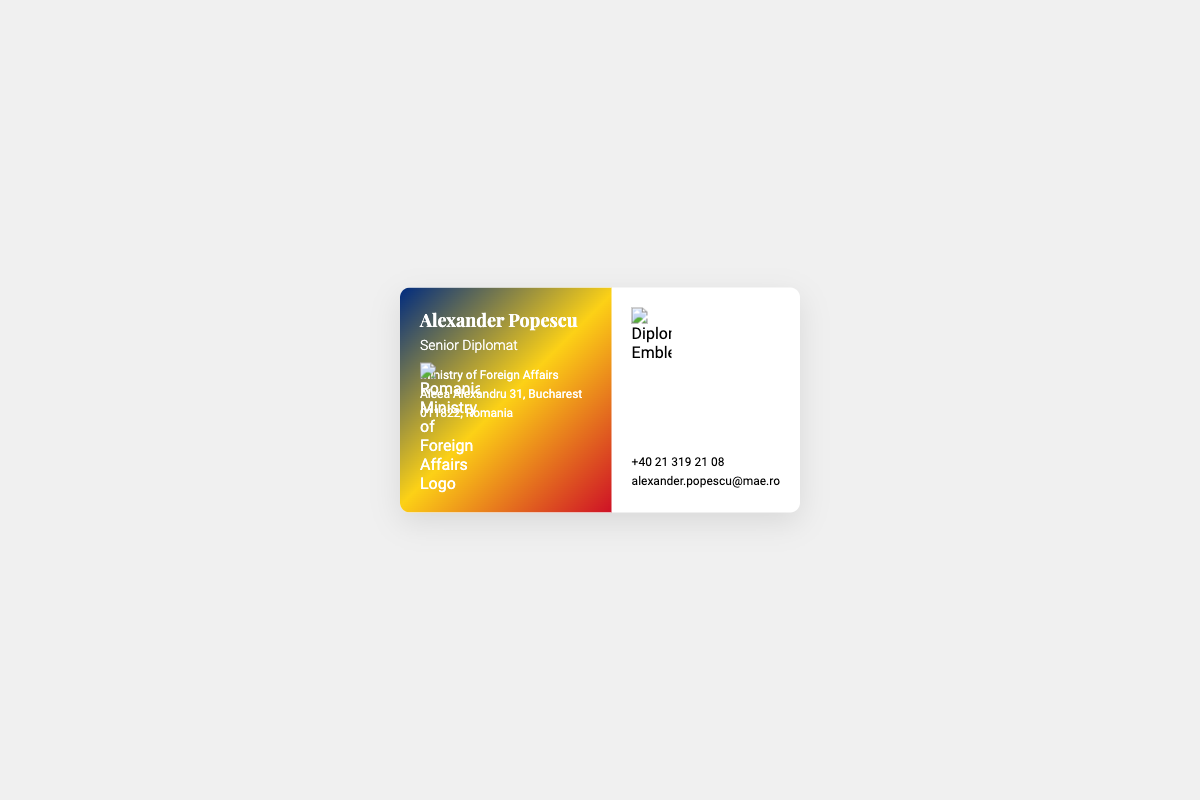What is the full name of the diplomat? The name of the diplomat is prominently displayed in the document as Alexander Popescu.
Answer: Alexander Popescu What is the position of Alexander Popescu? The position specified in the document is Senior Diplomat.
Answer: Senior Diplomat What is the address of the Ministry of Foreign Affairs? The document lists the ministry's address as Aleea Alexandru 31, Bucharest, 011822, Romania.
Answer: Aleea Alexandru 31, Bucharest, 011822, Romania What is the phone number provided on the business card? The phone number can be found in the contact information section, listed as +40 21 319 21 08.
Answer: +40 21 319 21 08 What is the email address for Alexander Popescu? The email address is provided in the document as alexander.popescu@mae.ro.
Answer: alexander.popescu@mae.ro What logo is displayed on the card? The document features the logo of the Romanian Ministry of Foreign Affairs prominently on the left side.
Answer: Romanian Ministry of Foreign Affairs Logo What emblem is featured on the business card? The card includes the Diplomatic Emblem of Romania on the right side.
Answer: Diplomatic Emblem What color gradient is used in the background of the left section? The left section of the card uses a gradient that transitions through blue, yellow, and red colors.
Answer: Blue, Yellow, Red gradient How is the business card structured? The card is divided into two sections, with the left for the diplomat's details and the right for contact information and the emblem.
Answer: Two sections 